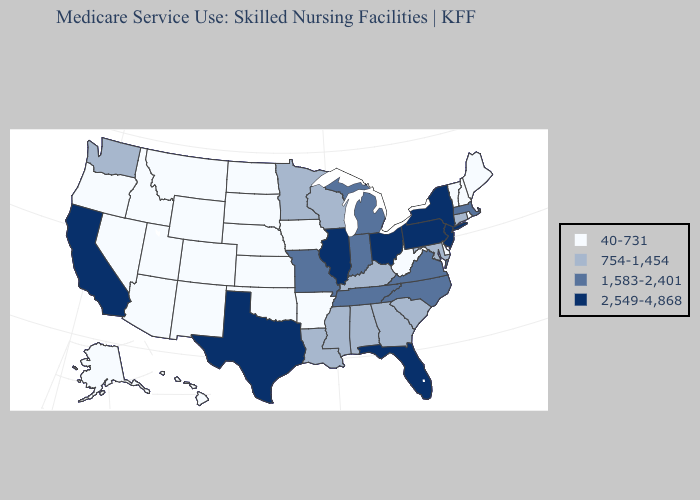What is the value of Maine?
Short answer required. 40-731. Among the states that border Minnesota , which have the highest value?
Write a very short answer. Wisconsin. Which states have the lowest value in the USA?
Quick response, please. Alaska, Arizona, Arkansas, Colorado, Delaware, Hawaii, Idaho, Iowa, Kansas, Maine, Montana, Nebraska, Nevada, New Hampshire, New Mexico, North Dakota, Oklahoma, Oregon, Rhode Island, South Dakota, Utah, Vermont, West Virginia, Wyoming. Does Virginia have the lowest value in the USA?
Keep it brief. No. What is the highest value in states that border Delaware?
Write a very short answer. 2,549-4,868. What is the lowest value in the USA?
Answer briefly. 40-731. What is the lowest value in the USA?
Answer briefly. 40-731. Among the states that border Kentucky , does Indiana have the lowest value?
Concise answer only. No. What is the highest value in the USA?
Be succinct. 2,549-4,868. Name the states that have a value in the range 1,583-2,401?
Keep it brief. Indiana, Massachusetts, Michigan, Missouri, North Carolina, Tennessee, Virginia. What is the highest value in the USA?
Be succinct. 2,549-4,868. What is the value of Nevada?
Be succinct. 40-731. What is the value of Wyoming?
Short answer required. 40-731. Name the states that have a value in the range 1,583-2,401?
Short answer required. Indiana, Massachusetts, Michigan, Missouri, North Carolina, Tennessee, Virginia. Which states have the lowest value in the USA?
Answer briefly. Alaska, Arizona, Arkansas, Colorado, Delaware, Hawaii, Idaho, Iowa, Kansas, Maine, Montana, Nebraska, Nevada, New Hampshire, New Mexico, North Dakota, Oklahoma, Oregon, Rhode Island, South Dakota, Utah, Vermont, West Virginia, Wyoming. 